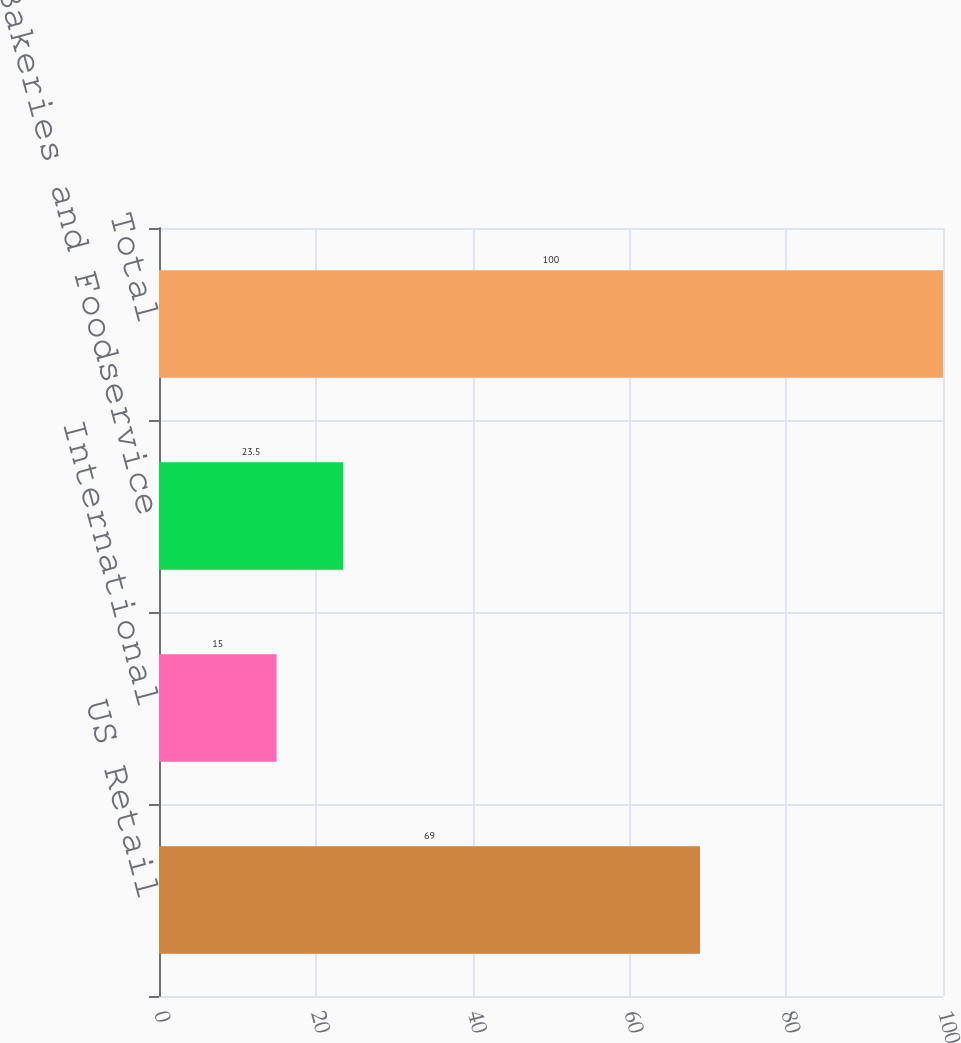<chart> <loc_0><loc_0><loc_500><loc_500><bar_chart><fcel>US Retail<fcel>International<fcel>Bakeries and Foodservice<fcel>Total<nl><fcel>69<fcel>15<fcel>23.5<fcel>100<nl></chart> 